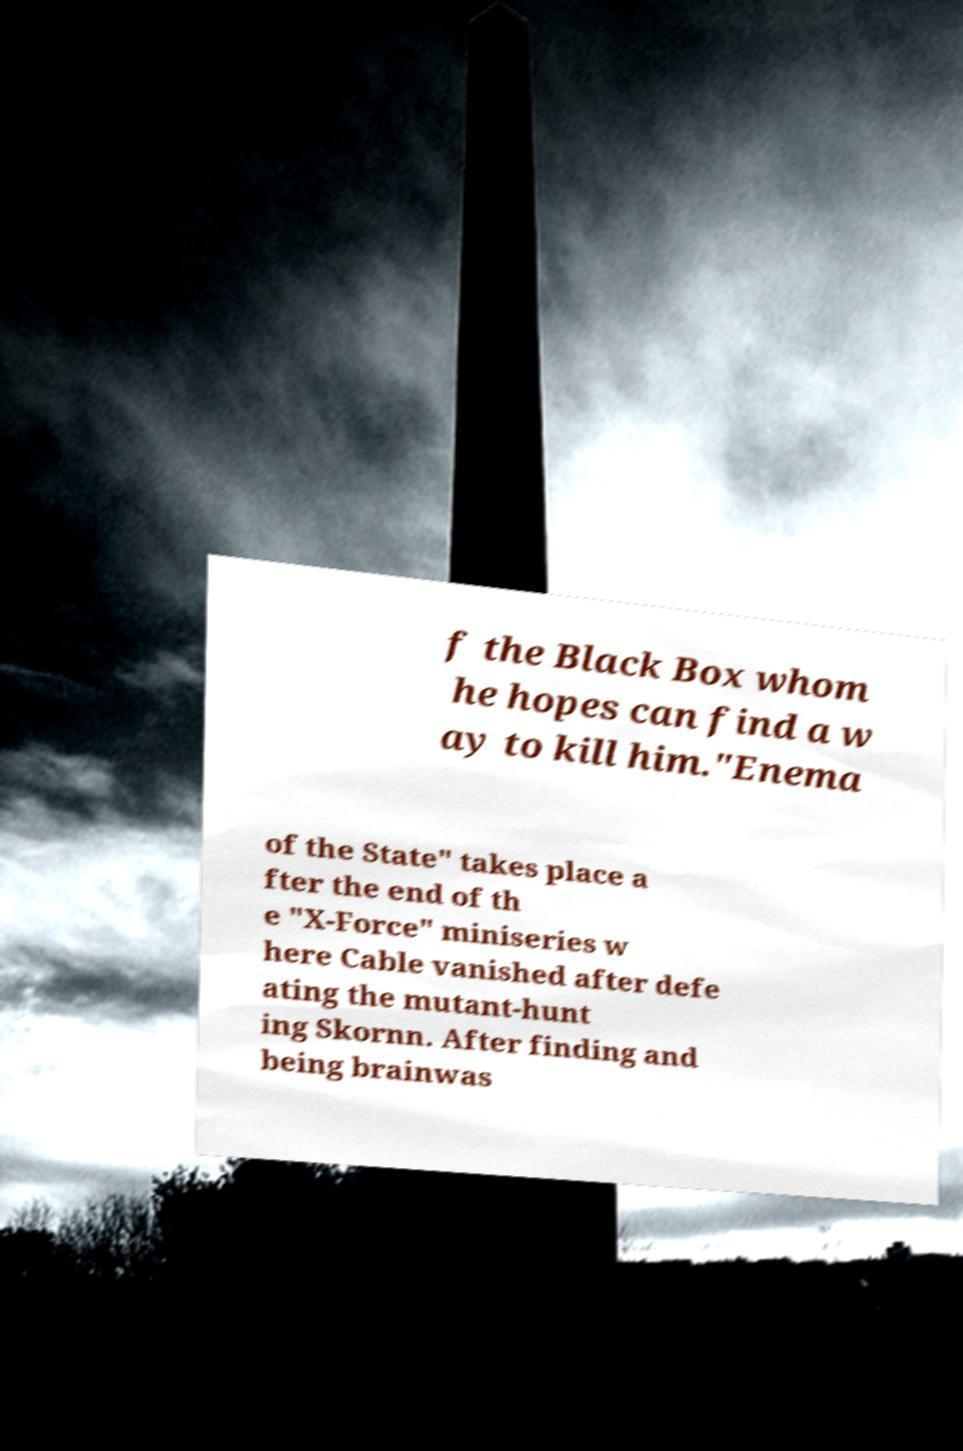Could you assist in decoding the text presented in this image and type it out clearly? f the Black Box whom he hopes can find a w ay to kill him."Enema of the State" takes place a fter the end of th e "X-Force" miniseries w here Cable vanished after defe ating the mutant-hunt ing Skornn. After finding and being brainwas 